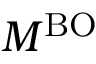<formula> <loc_0><loc_0><loc_500><loc_500>M ^ { B O }</formula> 